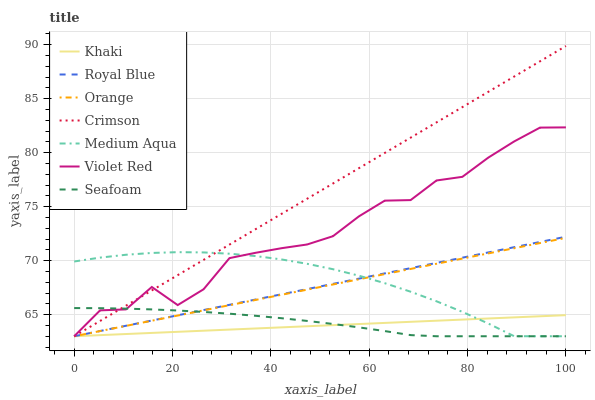Does Khaki have the minimum area under the curve?
Answer yes or no. Yes. Does Crimson have the maximum area under the curve?
Answer yes or no. Yes. Does Seafoam have the minimum area under the curve?
Answer yes or no. No. Does Seafoam have the maximum area under the curve?
Answer yes or no. No. Is Crimson the smoothest?
Answer yes or no. Yes. Is Violet Red the roughest?
Answer yes or no. Yes. Is Khaki the smoothest?
Answer yes or no. No. Is Khaki the roughest?
Answer yes or no. No. Does Violet Red have the lowest value?
Answer yes or no. Yes. Does Crimson have the highest value?
Answer yes or no. Yes. Does Seafoam have the highest value?
Answer yes or no. No. Does Medium Aqua intersect Royal Blue?
Answer yes or no. Yes. Is Medium Aqua less than Royal Blue?
Answer yes or no. No. Is Medium Aqua greater than Royal Blue?
Answer yes or no. No. 